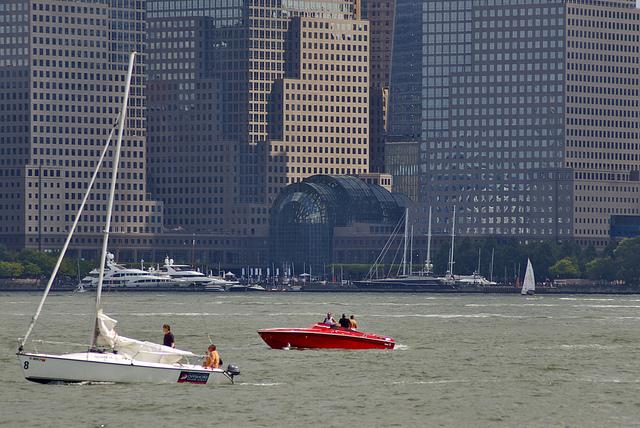What are the colors of the boats?
Answer briefly. Red and white. Are the boats in the water?
Give a very brief answer. Yes. Do you think this is in America?
Keep it brief. Yes. How many boats are there?
Answer briefly. 7. 